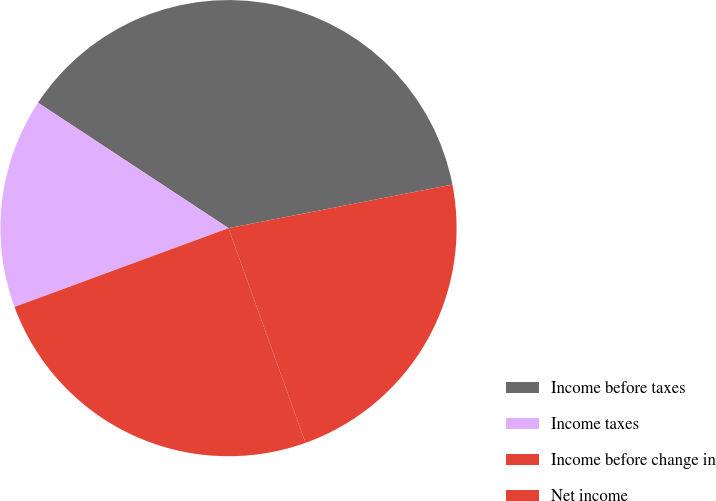Convert chart. <chart><loc_0><loc_0><loc_500><loc_500><pie_chart><fcel>Income before taxes<fcel>Income taxes<fcel>Income before change in<fcel>Net income<nl><fcel>37.67%<fcel>14.88%<fcel>24.86%<fcel>22.58%<nl></chart> 